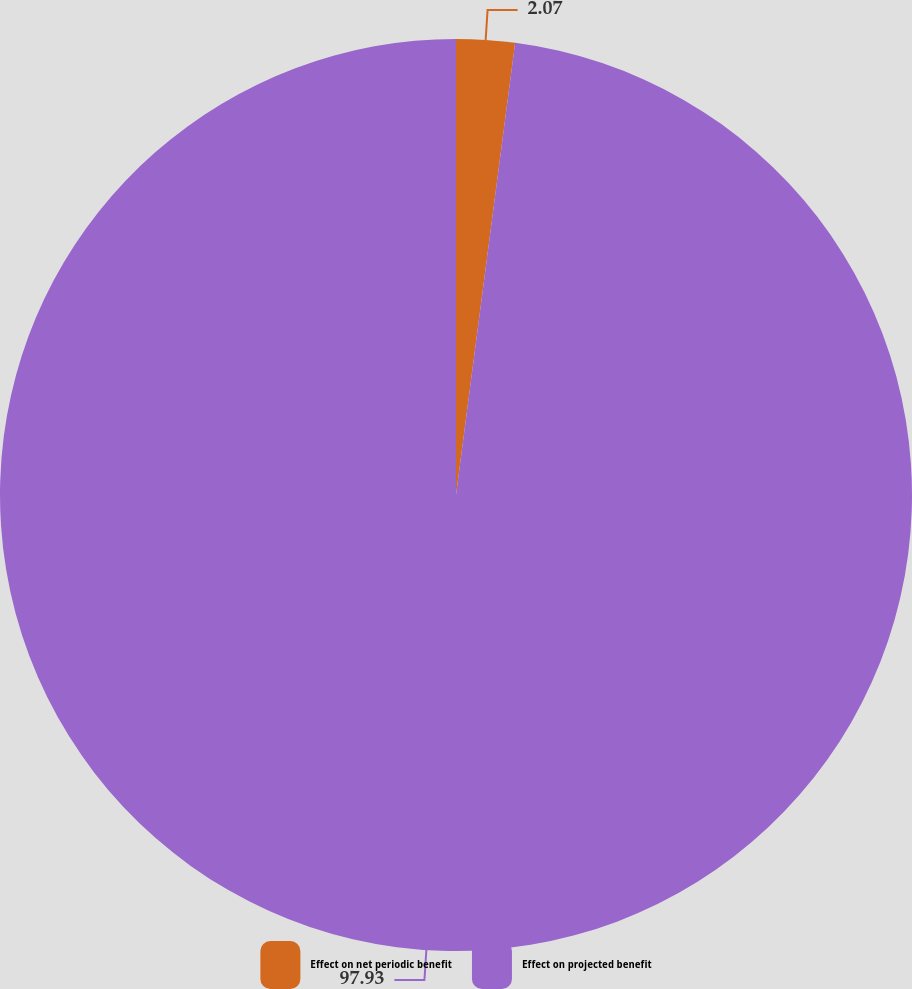<chart> <loc_0><loc_0><loc_500><loc_500><pie_chart><fcel>Effect on net periodic benefit<fcel>Effect on projected benefit<nl><fcel>2.07%<fcel>97.93%<nl></chart> 